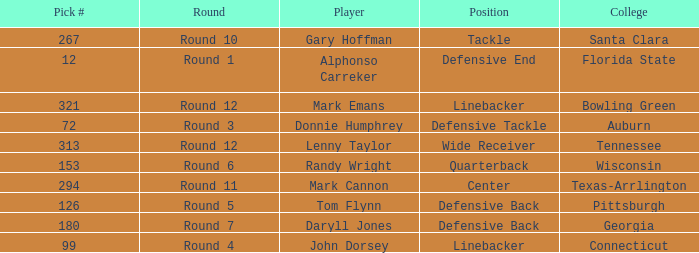In what Round was Pick #12 drafted? Round 1. 